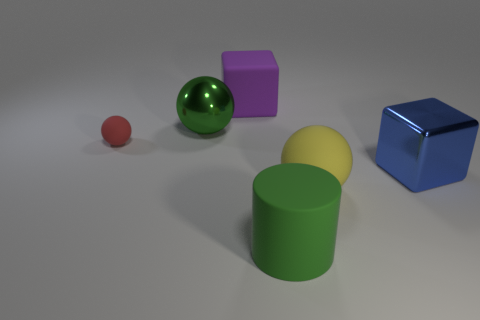Add 4 metallic spheres. How many objects exist? 10 Subtract all cylinders. How many objects are left? 5 Subtract all large blue cubes. Subtract all green rubber cylinders. How many objects are left? 4 Add 4 yellow matte things. How many yellow matte things are left? 5 Add 5 tiny yellow matte things. How many tiny yellow matte things exist? 5 Subtract 0 red blocks. How many objects are left? 6 